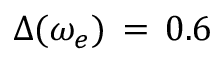<formula> <loc_0><loc_0><loc_500><loc_500>\Delta ( \omega _ { e } ) \, = \, 0 . 6 \</formula> 